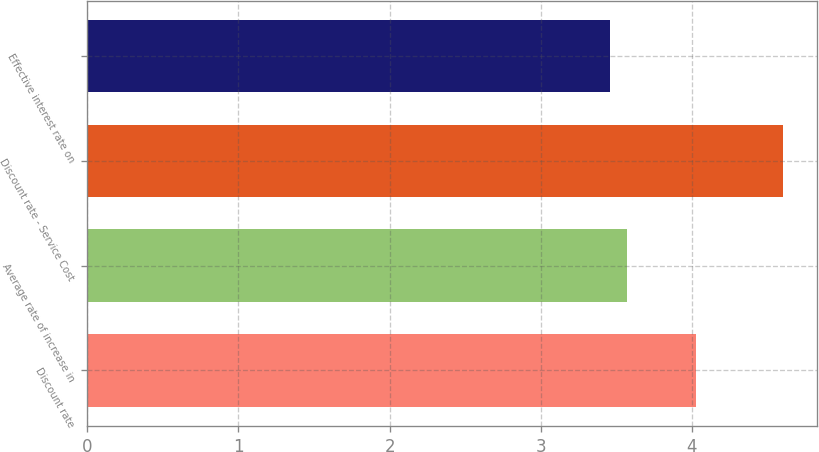Convert chart. <chart><loc_0><loc_0><loc_500><loc_500><bar_chart><fcel>Discount rate<fcel>Average rate of increase in<fcel>Discount rate - Service Cost<fcel>Effective interest rate on<nl><fcel>4.03<fcel>3.57<fcel>4.6<fcel>3.46<nl></chart> 